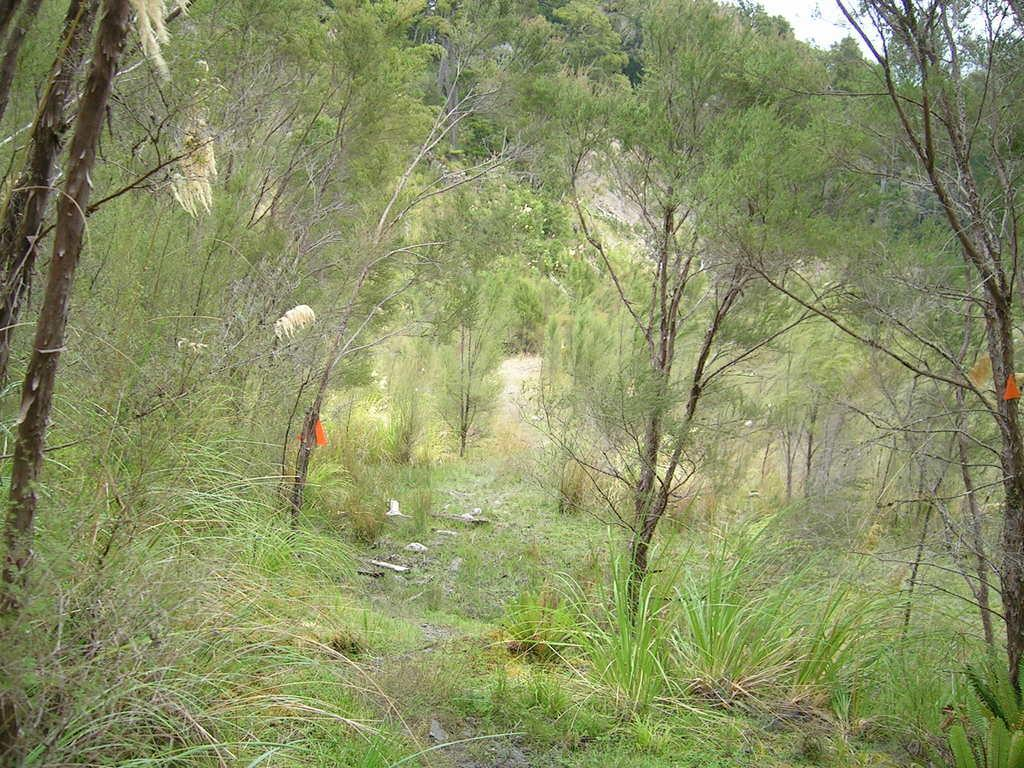What type of vegetation is in the center of the image? There are trees in the center of the image. What type of ground cover is at the bottom of the image? There is grass at the bottom of the image. What can be seen in the background of the image? The sky is visible in the background of the image. How many wristwatches are visible on the trees in the image? There are no wristwatches present on the trees in the image. What type of birds can be seen swimming in the grass at the bottom of the image? There are no birds, including ducks, visible in the grass at the bottom of the image. 